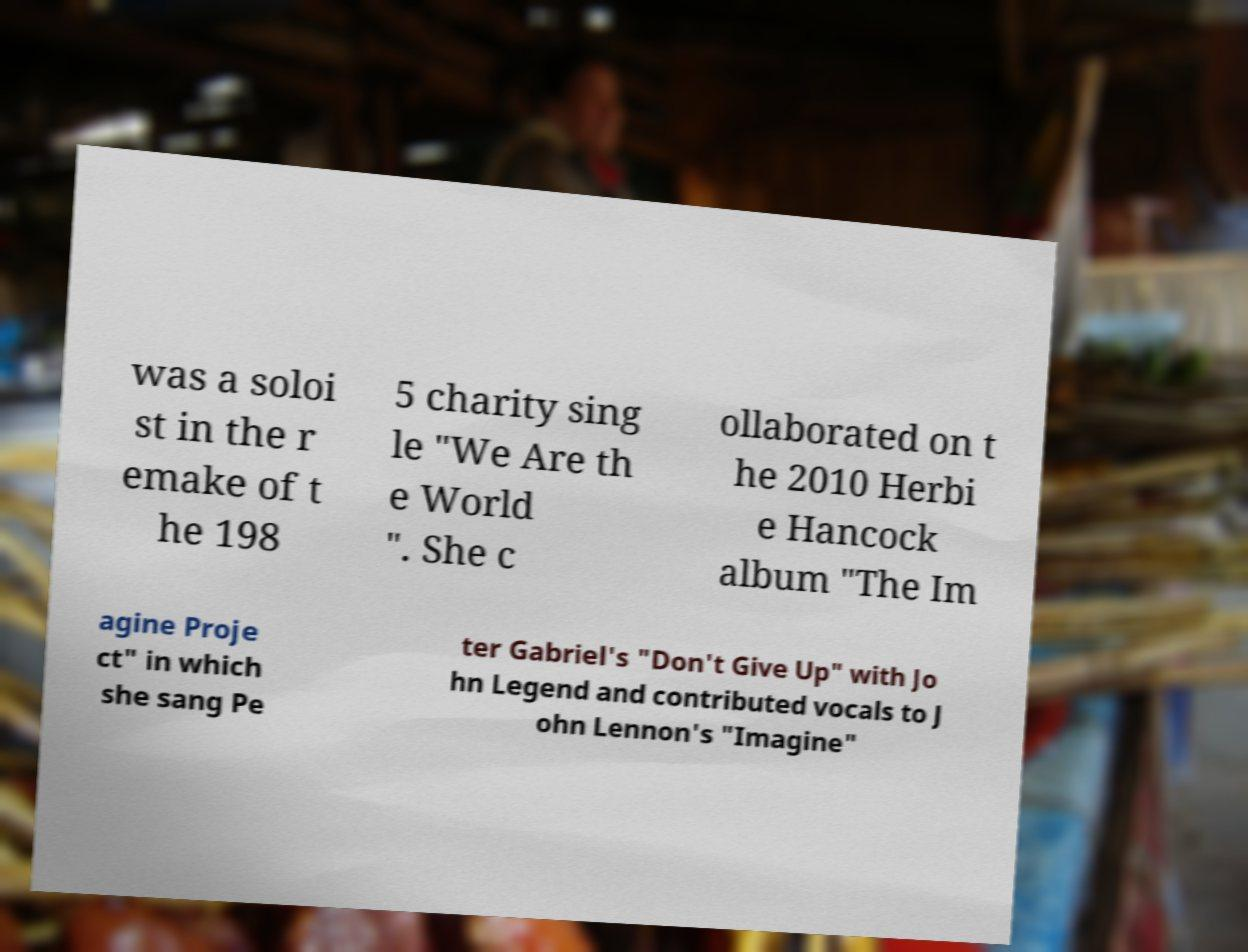Please read and relay the text visible in this image. What does it say? was a soloi st in the r emake of t he 198 5 charity sing le "We Are th e World ". She c ollaborated on t he 2010 Herbi e Hancock album "The Im agine Proje ct" in which she sang Pe ter Gabriel's "Don't Give Up" with Jo hn Legend and contributed vocals to J ohn Lennon's "Imagine" 